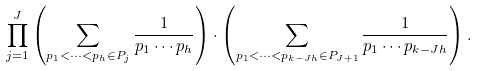Convert formula to latex. <formula><loc_0><loc_0><loc_500><loc_500>\prod _ { j = 1 } ^ { J } \left ( \sum _ { p _ { 1 } < \cdots < p _ { h } \in P _ { j } } \frac { 1 } { p _ { 1 } \cdots p _ { h } } \right ) \cdot \left ( \sum _ { p _ { 1 } < \cdots < p _ { k - J h } \in P _ { J + 1 } } \frac { 1 } { p _ { 1 } \cdots p _ { k - J h } } \right ) .</formula> 